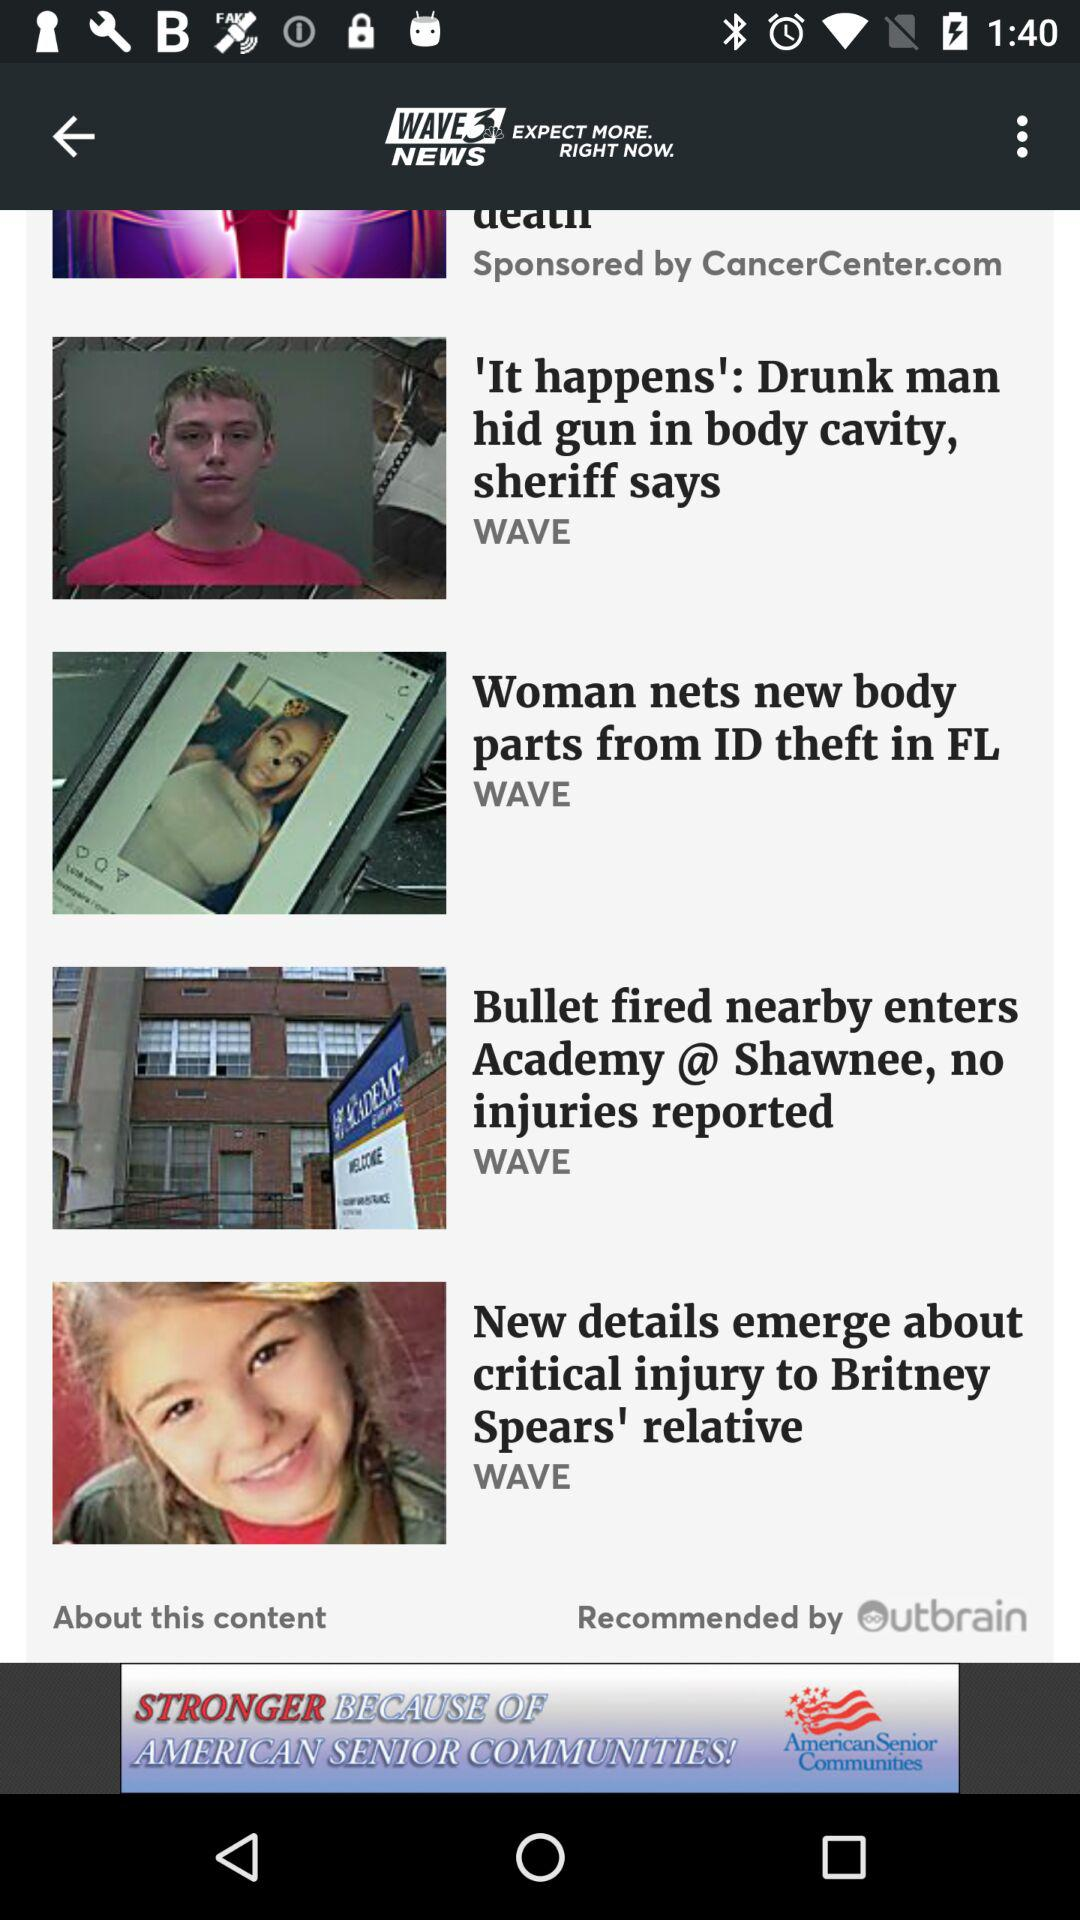By whom is the app recommended? The app is recommended by "Outbrain". 